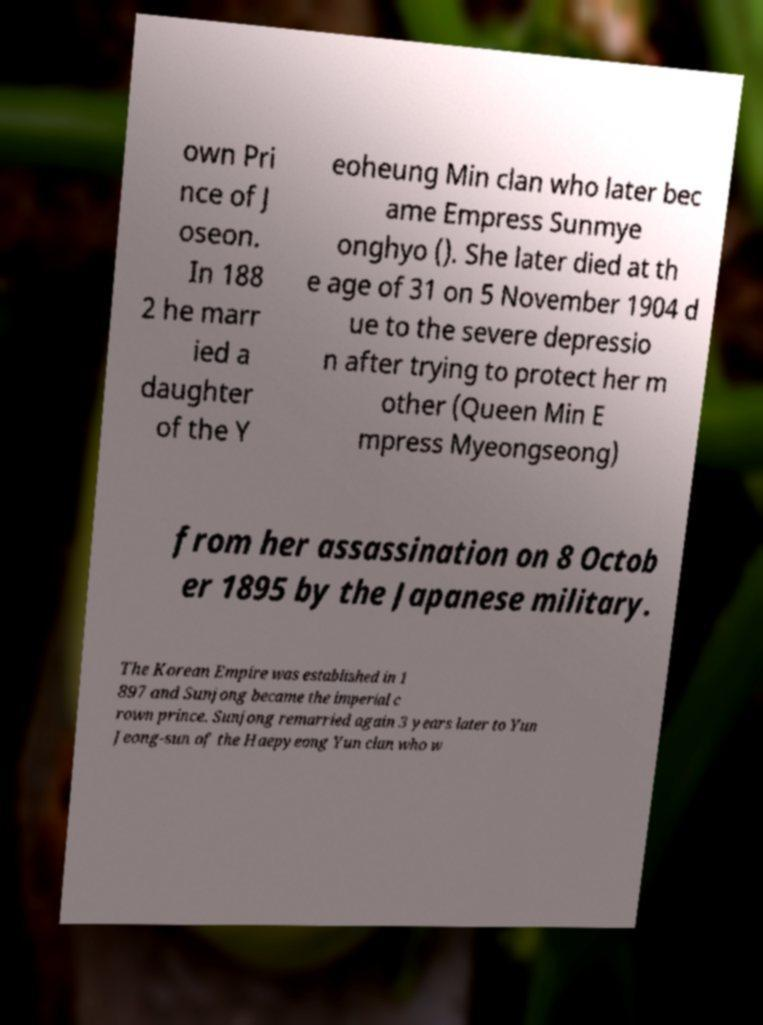Could you assist in decoding the text presented in this image and type it out clearly? own Pri nce of J oseon. In 188 2 he marr ied a daughter of the Y eoheung Min clan who later bec ame Empress Sunmye onghyo (). She later died at th e age of 31 on 5 November 1904 d ue to the severe depressio n after trying to protect her m other (Queen Min E mpress Myeongseong) from her assassination on 8 Octob er 1895 by the Japanese military. The Korean Empire was established in 1 897 and Sunjong became the imperial c rown prince. Sunjong remarried again 3 years later to Yun Jeong-sun of the Haepyeong Yun clan who w 